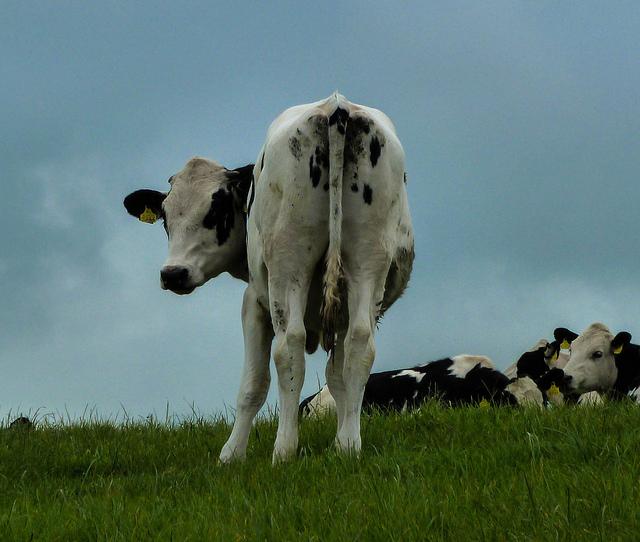Which ear is tagged?
Be succinct. Right. What is the long furry thing at the back of the animal?
Keep it brief. Tail. What type of animal's are pictured?
Give a very brief answer. Cows. What color is the grass?
Concise answer only. Green. What are these cows doing?
Quick response, please. Grazing. Is the cow eating grass?
Quick response, please. No. How big is the cow's nose?
Short answer required. Big. 